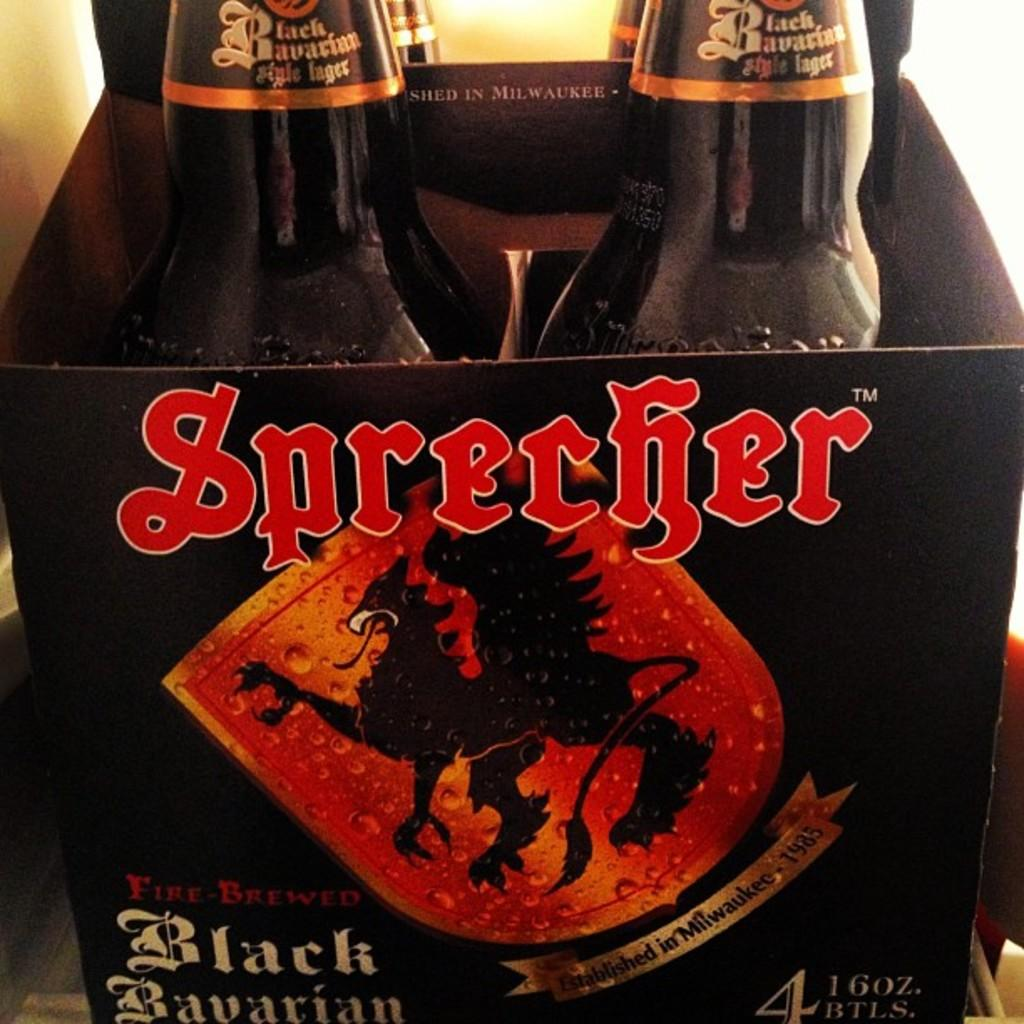<image>
Render a clear and concise summary of the photo. A four pack of Sprecher black Bavarian beer. 